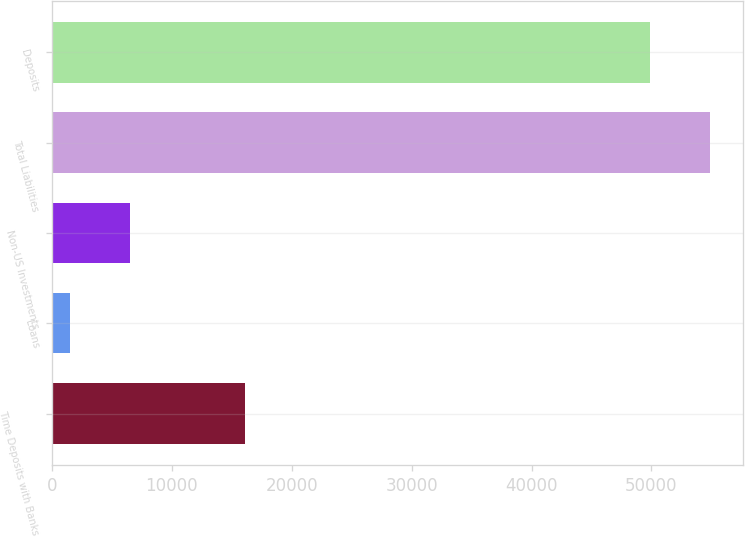<chart> <loc_0><loc_0><loc_500><loc_500><bar_chart><fcel>Time Deposits with Banks<fcel>Loans<fcel>Non-US Investments<fcel>Total Liabilities<fcel>Deposits<nl><fcel>16106.9<fcel>1490.2<fcel>6553.51<fcel>54918<fcel>49854.7<nl></chart> 